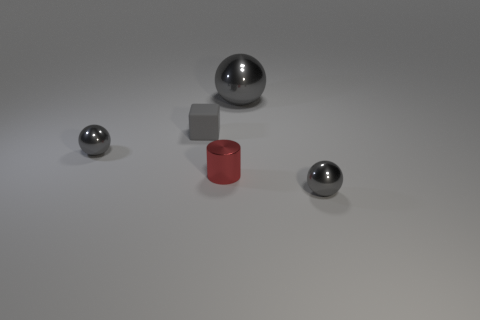Add 1 small metallic cylinders. How many objects exist? 6 Subtract all cylinders. How many objects are left? 4 Add 5 tiny green blocks. How many tiny green blocks exist? 5 Subtract 0 yellow blocks. How many objects are left? 5 Subtract all yellow metallic things. Subtract all gray rubber things. How many objects are left? 4 Add 2 big gray metallic things. How many big gray metallic things are left? 3 